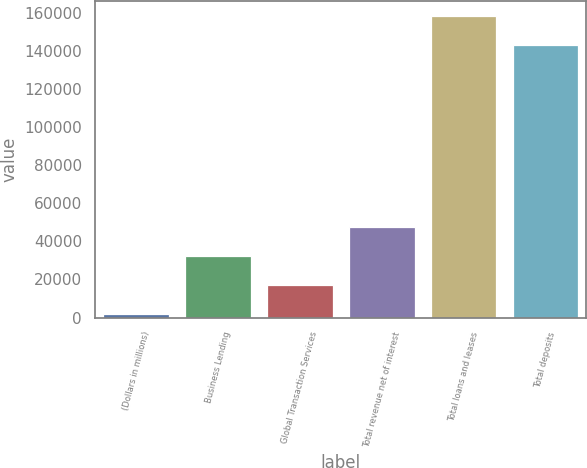Convert chart to OTSL. <chart><loc_0><loc_0><loc_500><loc_500><bar_chart><fcel>(Dollars in millions)<fcel>Business Lending<fcel>Global Transaction Services<fcel>Total revenue net of interest<fcel>Total loans and leases<fcel>Total deposits<nl><fcel>2016<fcel>32201.6<fcel>17108.8<fcel>47294.4<fcel>158326<fcel>143233<nl></chart> 